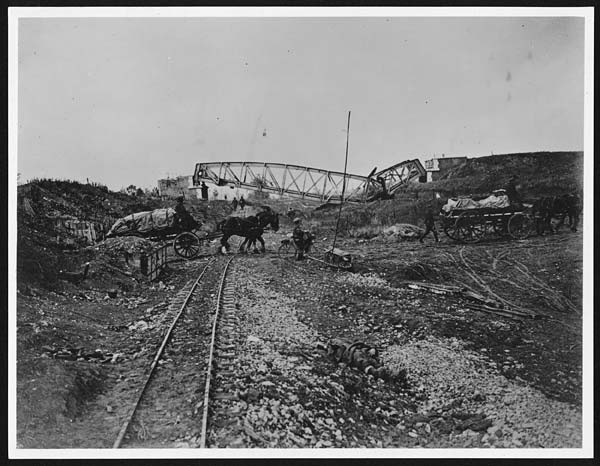What challenges might the workers have faced while building the railroad during this time period? Workers constructing railroads during this era would have encountered numerous challenges. These include harsh working conditions, such as extreme weather and long hours, and reliance on manual labor, which was physically demanding and often dangerous due to the lack of modern safety equipment. Safety hazards, such as falling materials and occupational injuries, were common. Health concerns were exacerbated by exposure to dust and noise, compounded by limited access to healthcare. Poor living conditions and isolation from urban centers also contributed to the difficulties faced by these workers. Despite these hardships, their efforts were crucial in transforming transportation and trade during this period. 